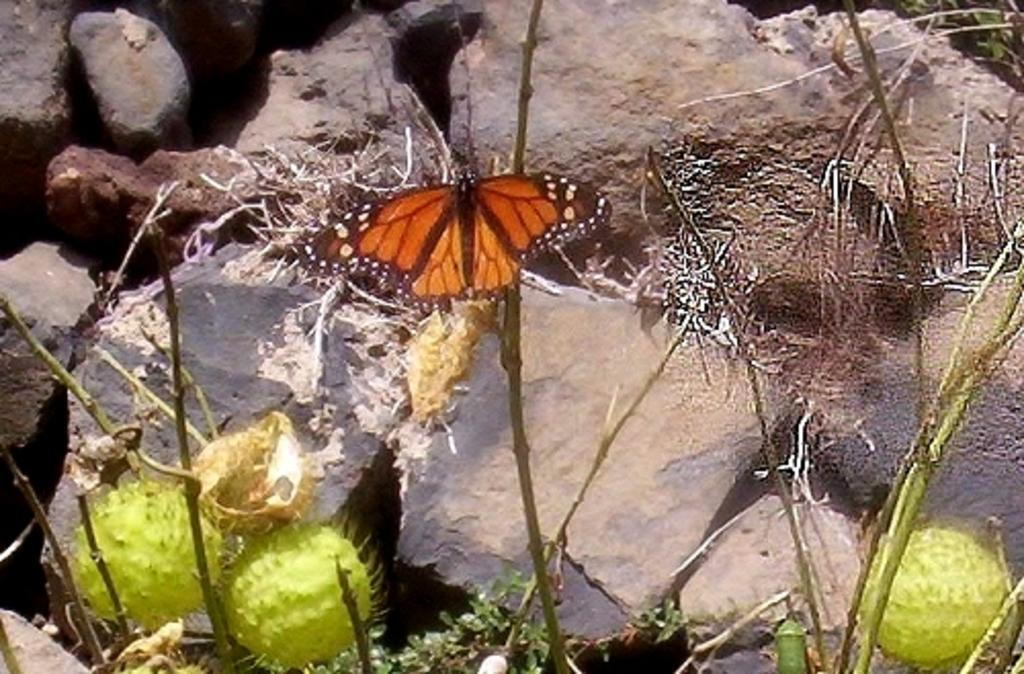What can be seen in abundance in the image? There are many stems in the image. Is there any wildlife present in the image? Yes, there is a butterfly on one of the stems. What can be seen in the distance in the image? There are rocks visible in the background of the image. What class is the butterfly attending in the image? Butterflies do not attend classes, so this question is not applicable to the image. 